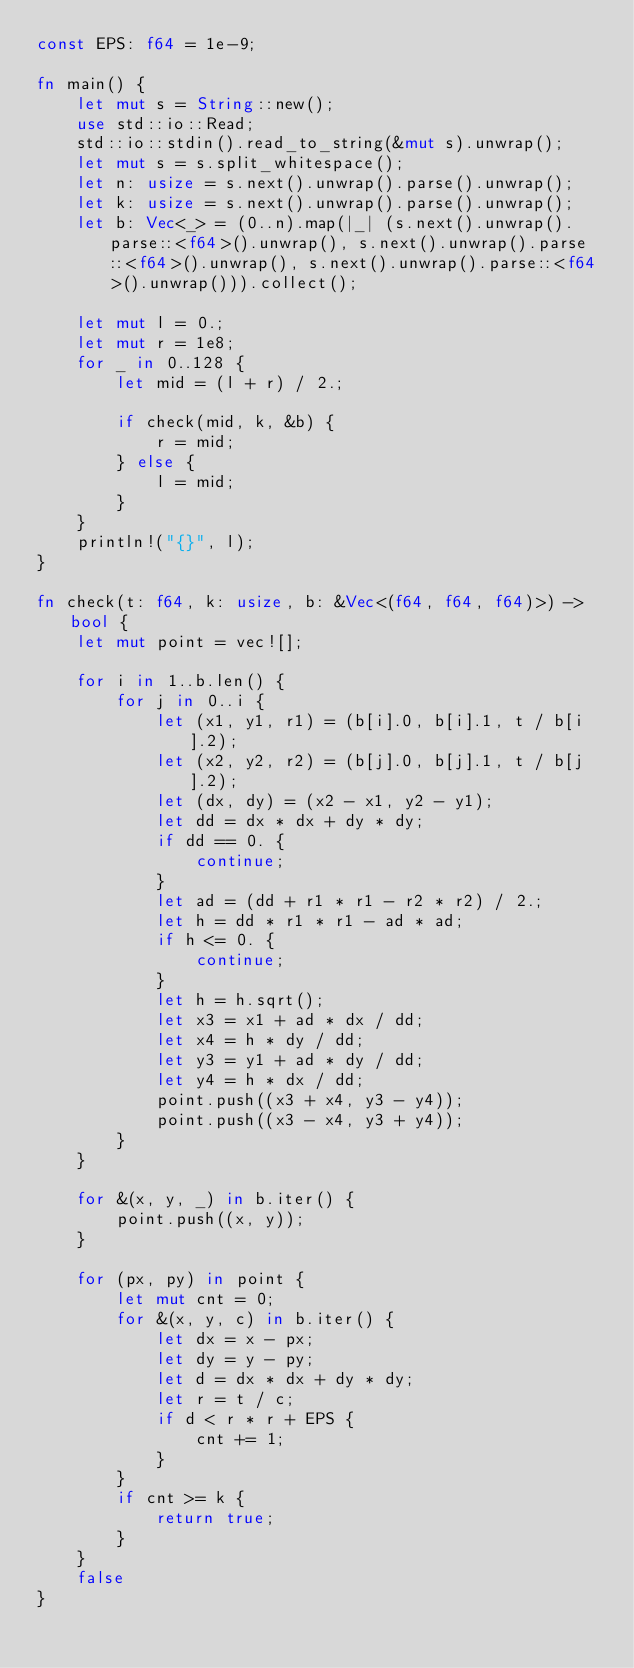<code> <loc_0><loc_0><loc_500><loc_500><_Rust_>const EPS: f64 = 1e-9;

fn main() {
	let mut s = String::new();
	use std::io::Read;
	std::io::stdin().read_to_string(&mut s).unwrap();
	let mut s = s.split_whitespace();
	let n: usize = s.next().unwrap().parse().unwrap();
	let k: usize = s.next().unwrap().parse().unwrap();
	let b: Vec<_> = (0..n).map(|_| (s.next().unwrap().parse::<f64>().unwrap(), s.next().unwrap().parse::<f64>().unwrap(), s.next().unwrap().parse::<f64>().unwrap())).collect();

	let mut l = 0.;
	let mut r = 1e8;
	for _ in 0..128 {
		let mid = (l + r) / 2.;

		if check(mid, k, &b) {
			r = mid;
		} else {
			l = mid;
		}
	}
	println!("{}", l);
}

fn check(t: f64, k: usize, b: &Vec<(f64, f64, f64)>) -> bool {
	let mut point = vec![];

	for i in 1..b.len() {
		for j in 0..i {
			let (x1, y1, r1) = (b[i].0, b[i].1, t / b[i].2);
			let (x2, y2, r2) = (b[j].0, b[j].1, t / b[j].2);
			let (dx, dy) = (x2 - x1, y2 - y1);
			let dd = dx * dx + dy * dy;
			if dd == 0. {
				continue;
			}
			let ad = (dd + r1 * r1 - r2 * r2) / 2.;
			let h = dd * r1 * r1 - ad * ad;
			if h <= 0. {
				continue;
			}
			let h = h.sqrt();
			let x3 = x1 + ad * dx / dd;
			let x4 = h * dy / dd;
			let y3 = y1 + ad * dy / dd;
			let y4 = h * dx / dd;
			point.push((x3 + x4, y3 - y4));
			point.push((x3 - x4, y3 + y4));
		}
	}

	for &(x, y, _) in b.iter() {
		point.push((x, y));
	}

	for (px, py) in point {
		let mut cnt = 0;
		for &(x, y, c) in b.iter() {
			let dx = x - px;
			let dy = y - py;
			let d = dx * dx + dy * dy;
			let r = t / c;
			if d < r * r + EPS {
				cnt += 1;
			}
		}
		if cnt >= k {
			return true;
		}
	}
	false
}
</code> 